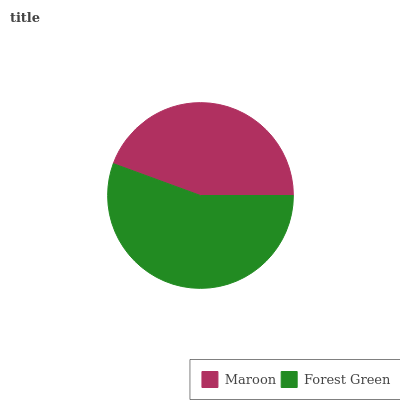Is Maroon the minimum?
Answer yes or no. Yes. Is Forest Green the maximum?
Answer yes or no. Yes. Is Forest Green the minimum?
Answer yes or no. No. Is Forest Green greater than Maroon?
Answer yes or no. Yes. Is Maroon less than Forest Green?
Answer yes or no. Yes. Is Maroon greater than Forest Green?
Answer yes or no. No. Is Forest Green less than Maroon?
Answer yes or no. No. Is Forest Green the high median?
Answer yes or no. Yes. Is Maroon the low median?
Answer yes or no. Yes. Is Maroon the high median?
Answer yes or no. No. Is Forest Green the low median?
Answer yes or no. No. 